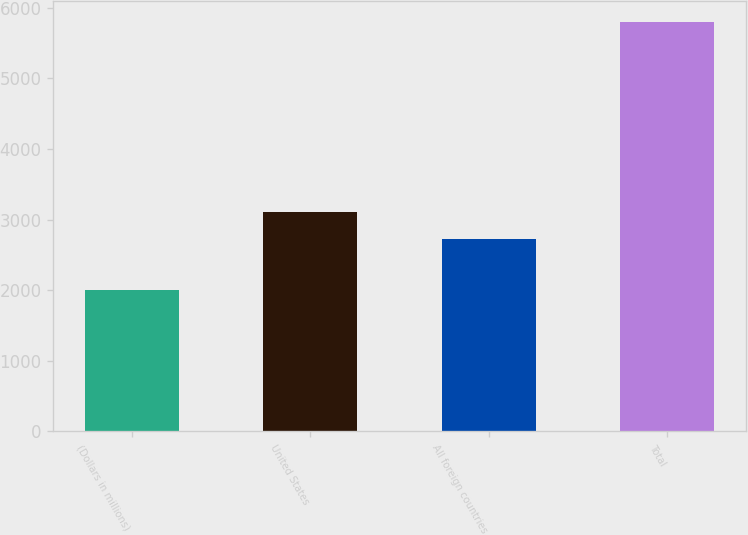Convert chart. <chart><loc_0><loc_0><loc_500><loc_500><bar_chart><fcel>(Dollars in millions)<fcel>United States<fcel>All foreign countries<fcel>Total<nl><fcel>2003<fcel>3105.7<fcel>2726<fcel>5800<nl></chart> 